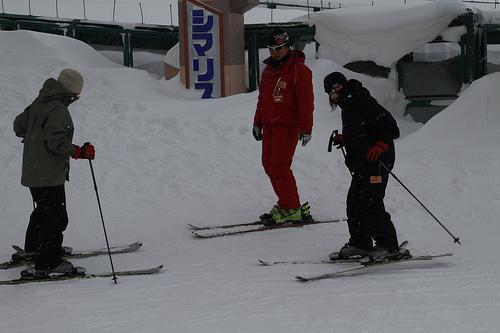How many people are there?
Give a very brief answer. 3. 